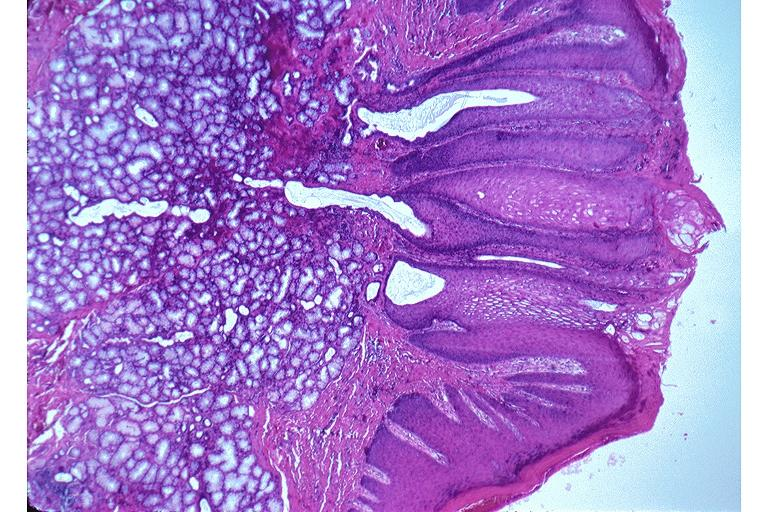does syndactyly show nicotine stomatitis?
Answer the question using a single word or phrase. No 